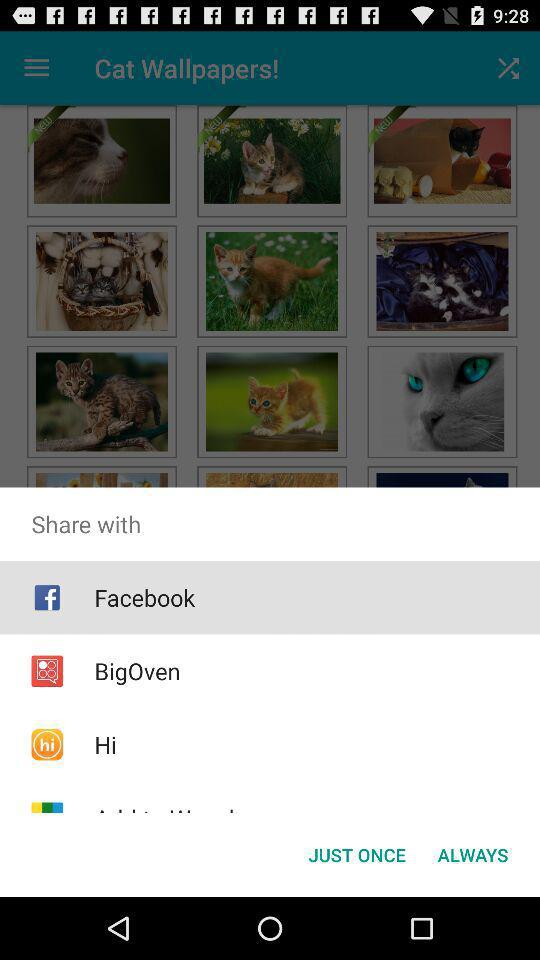Which application has been selected? The selected application is "Facebook". 